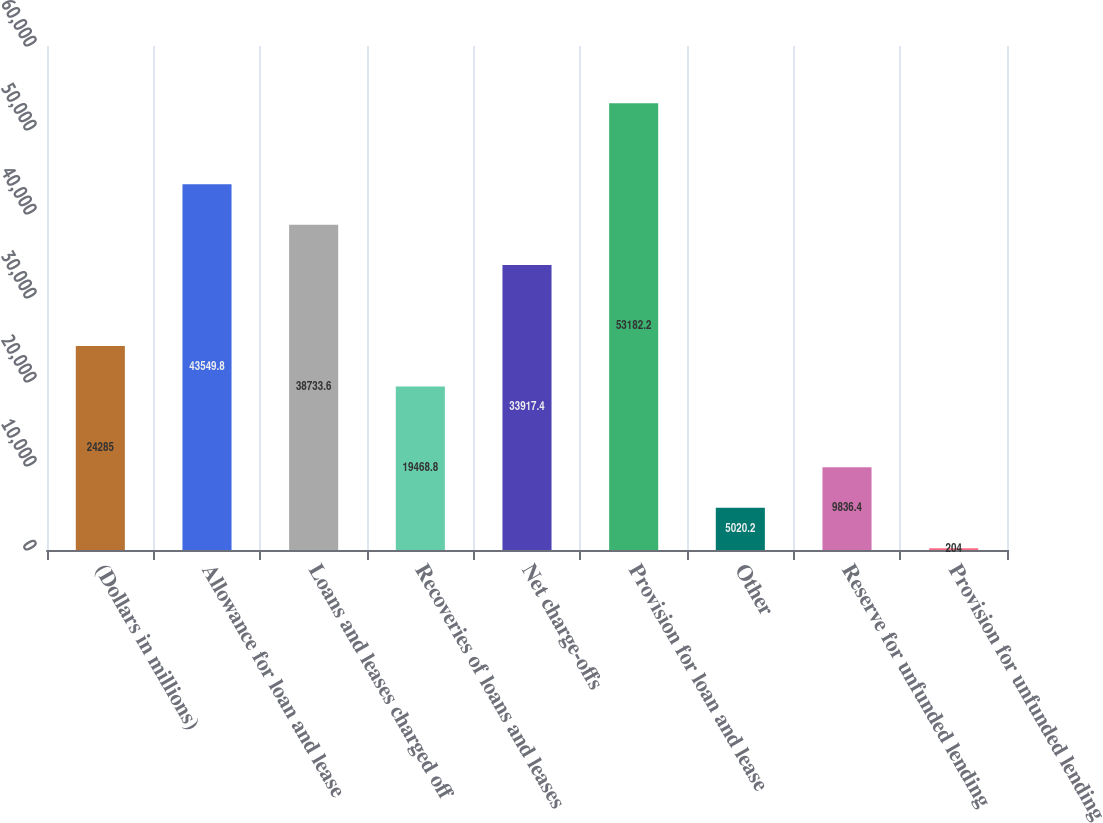Convert chart. <chart><loc_0><loc_0><loc_500><loc_500><bar_chart><fcel>(Dollars in millions)<fcel>Allowance for loan and lease<fcel>Loans and leases charged off<fcel>Recoveries of loans and leases<fcel>Net charge-offs<fcel>Provision for loan and lease<fcel>Other<fcel>Reserve for unfunded lending<fcel>Provision for unfunded lending<nl><fcel>24285<fcel>43549.8<fcel>38733.6<fcel>19468.8<fcel>33917.4<fcel>53182.2<fcel>5020.2<fcel>9836.4<fcel>204<nl></chart> 